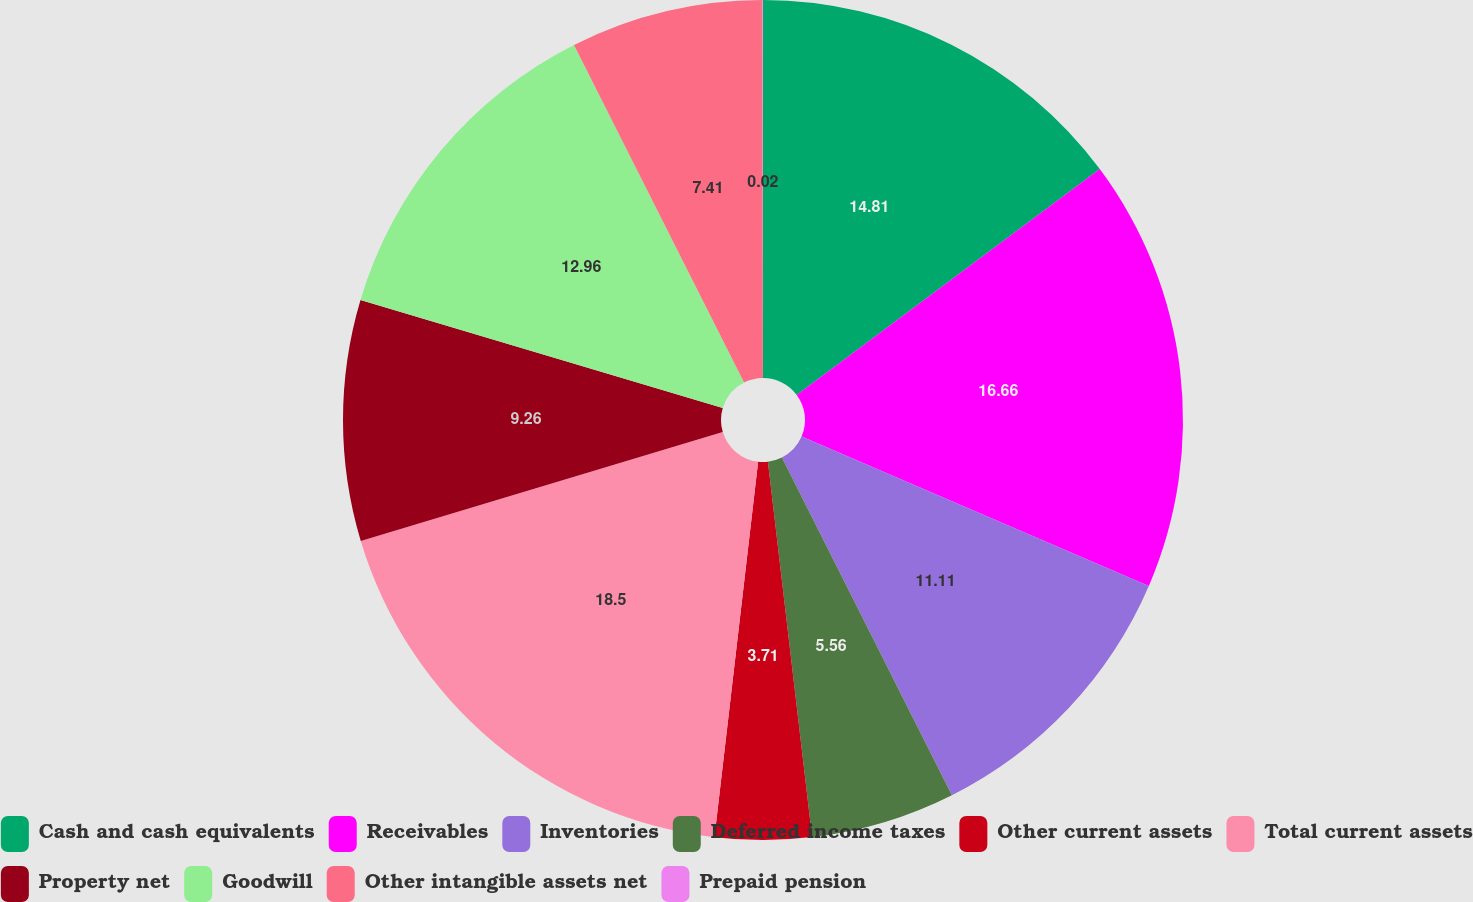<chart> <loc_0><loc_0><loc_500><loc_500><pie_chart><fcel>Cash and cash equivalents<fcel>Receivables<fcel>Inventories<fcel>Deferred income taxes<fcel>Other current assets<fcel>Total current assets<fcel>Property net<fcel>Goodwill<fcel>Other intangible assets net<fcel>Prepaid pension<nl><fcel>14.81%<fcel>16.66%<fcel>11.11%<fcel>5.56%<fcel>3.71%<fcel>18.51%<fcel>9.26%<fcel>12.96%<fcel>7.41%<fcel>0.02%<nl></chart> 